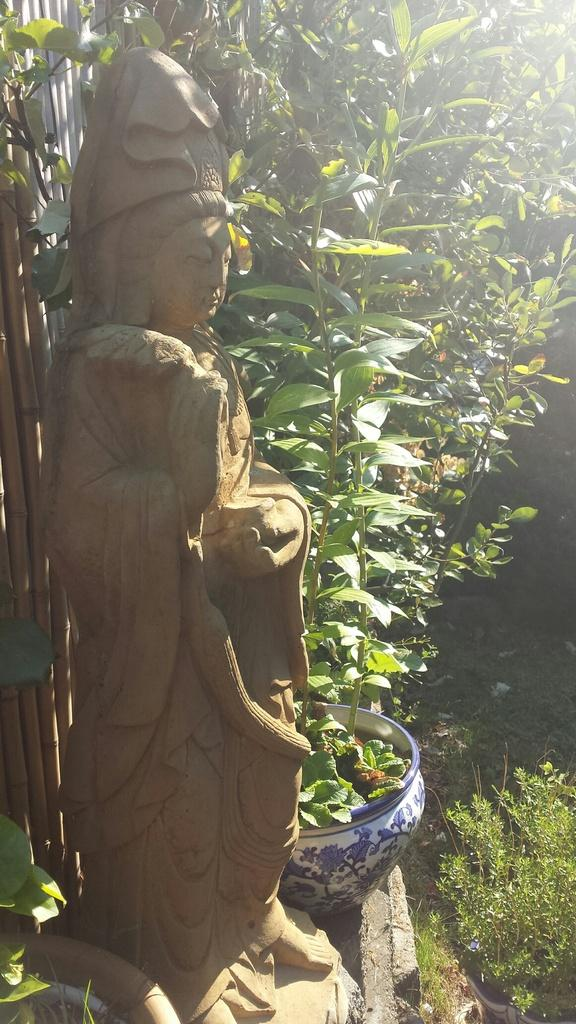What is located on the left side of the image? There is a statue on the left side of the image. What can be seen in the middle of the image? There are plants and trees in the middle of the image. How many wrens can be seen sleeping on the statue in the image? There are no wrens present in the image, and the statue is not depicted as a place for sleeping. 